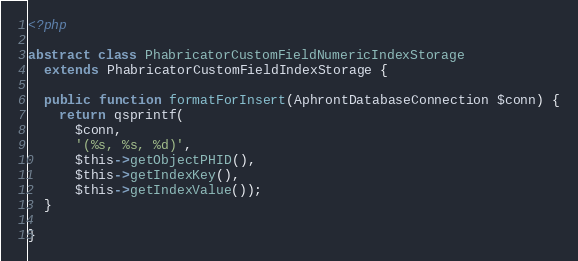Convert code to text. <code><loc_0><loc_0><loc_500><loc_500><_PHP_><?php

abstract class PhabricatorCustomFieldNumericIndexStorage
  extends PhabricatorCustomFieldIndexStorage {

  public function formatForInsert(AphrontDatabaseConnection $conn) {
    return qsprintf(
      $conn,
      '(%s, %s, %d)',
      $this->getObjectPHID(),
      $this->getIndexKey(),
      $this->getIndexValue());
  }

}
</code> 